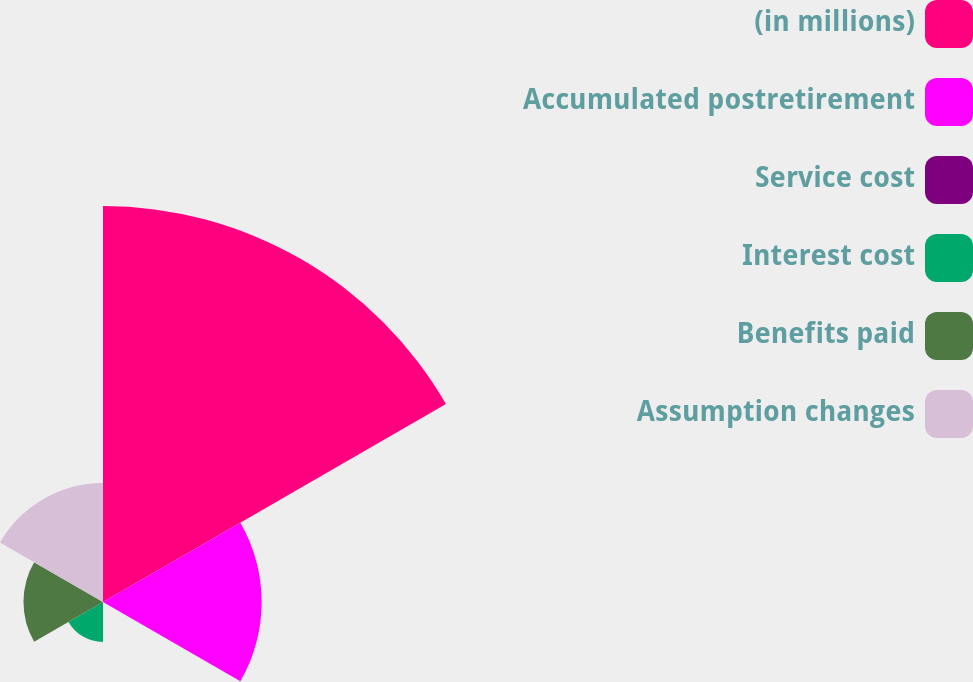<chart> <loc_0><loc_0><loc_500><loc_500><pie_chart><fcel>(in millions)<fcel>Accumulated postretirement<fcel>Service cost<fcel>Interest cost<fcel>Benefits paid<fcel>Assumption changes<nl><fcel>49.9%<fcel>19.99%<fcel>0.05%<fcel>5.03%<fcel>10.02%<fcel>15.0%<nl></chart> 